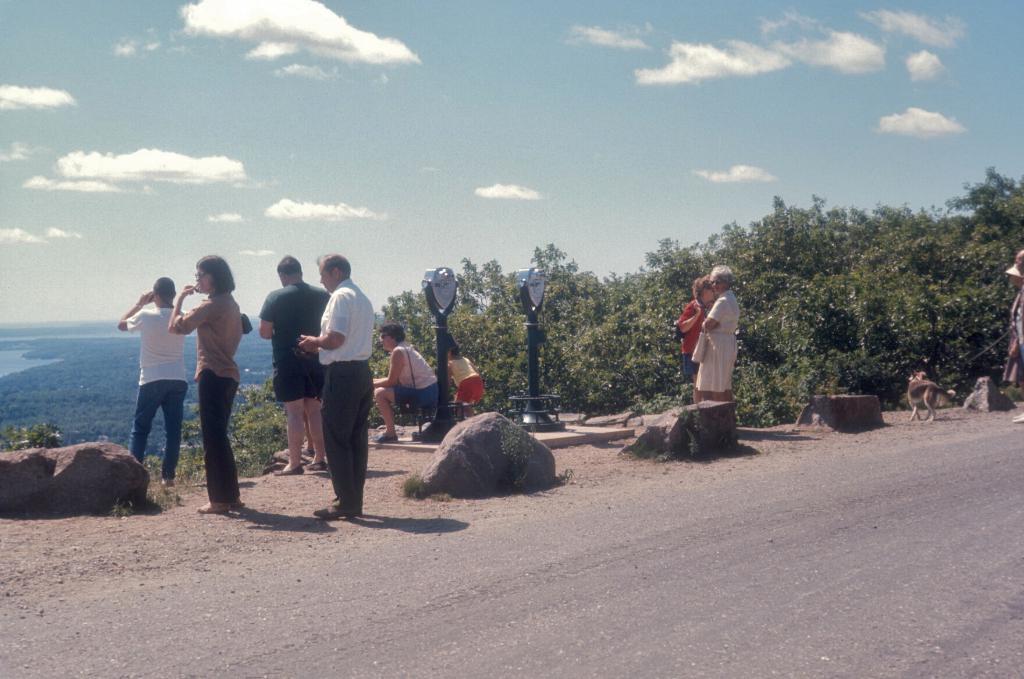Describe this image in one or two sentences. This image consists of many people. At the bottom, there is a road. To the right, there are plants. In the background, there are clouds in the sky. To the left, there is an ocean. 